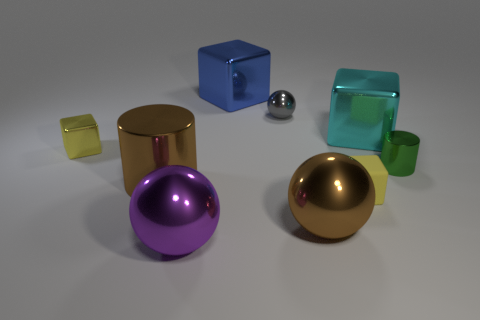Subtract all balls. How many objects are left? 6 Add 1 brown shiny objects. How many brown shiny objects are left? 3 Add 8 brown rubber objects. How many brown rubber objects exist? 8 Subtract 0 gray cubes. How many objects are left? 9 Subtract all brown things. Subtract all yellow shiny things. How many objects are left? 6 